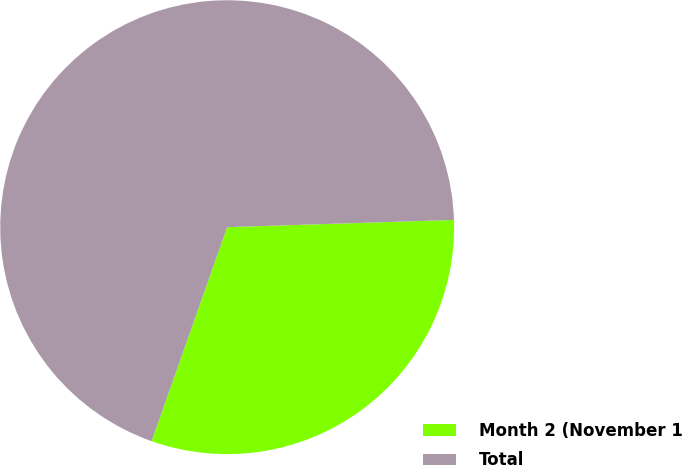<chart> <loc_0><loc_0><loc_500><loc_500><pie_chart><fcel>Month 2 (November 1<fcel>Total<nl><fcel>30.91%<fcel>69.09%<nl></chart> 